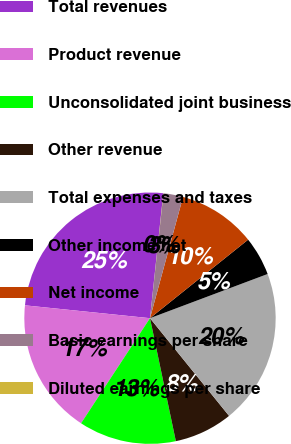Convert chart to OTSL. <chart><loc_0><loc_0><loc_500><loc_500><pie_chart><fcel>Total revenues<fcel>Product revenue<fcel>Unconsolidated joint business<fcel>Other revenue<fcel>Total expenses and taxes<fcel>Other income net<fcel>Net income<fcel>Basic earnings per share<fcel>Diluted earnings per share<nl><fcel>25.06%<fcel>17.39%<fcel>12.54%<fcel>7.53%<fcel>19.89%<fcel>5.02%<fcel>10.03%<fcel>2.52%<fcel>0.02%<nl></chart> 